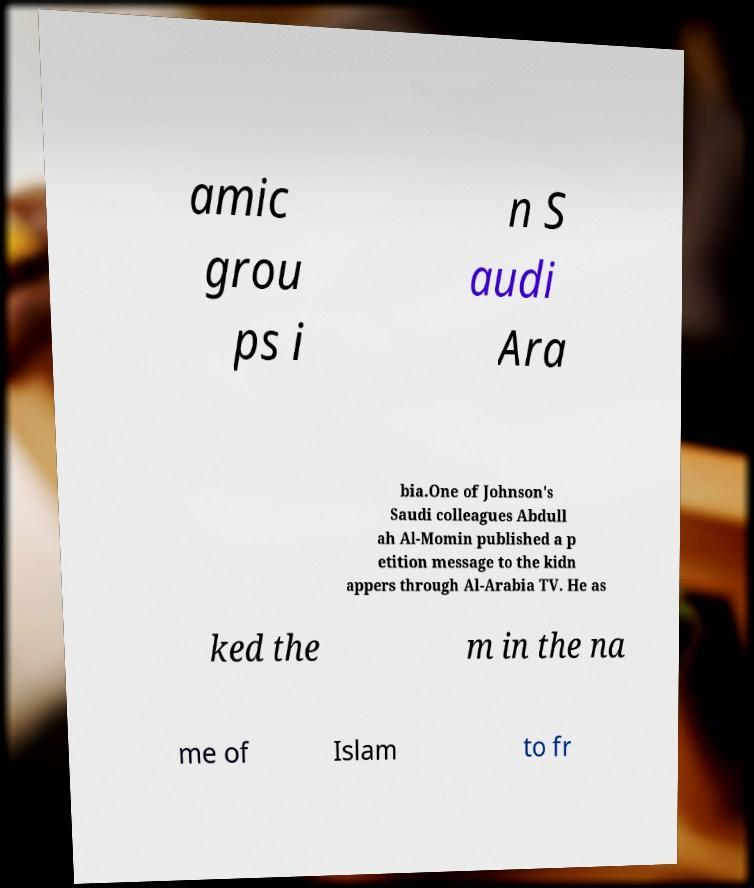There's text embedded in this image that I need extracted. Can you transcribe it verbatim? amic grou ps i n S audi Ara bia.One of Johnson's Saudi colleagues Abdull ah Al-Momin published a p etition message to the kidn appers through Al-Arabia TV. He as ked the m in the na me of Islam to fr 